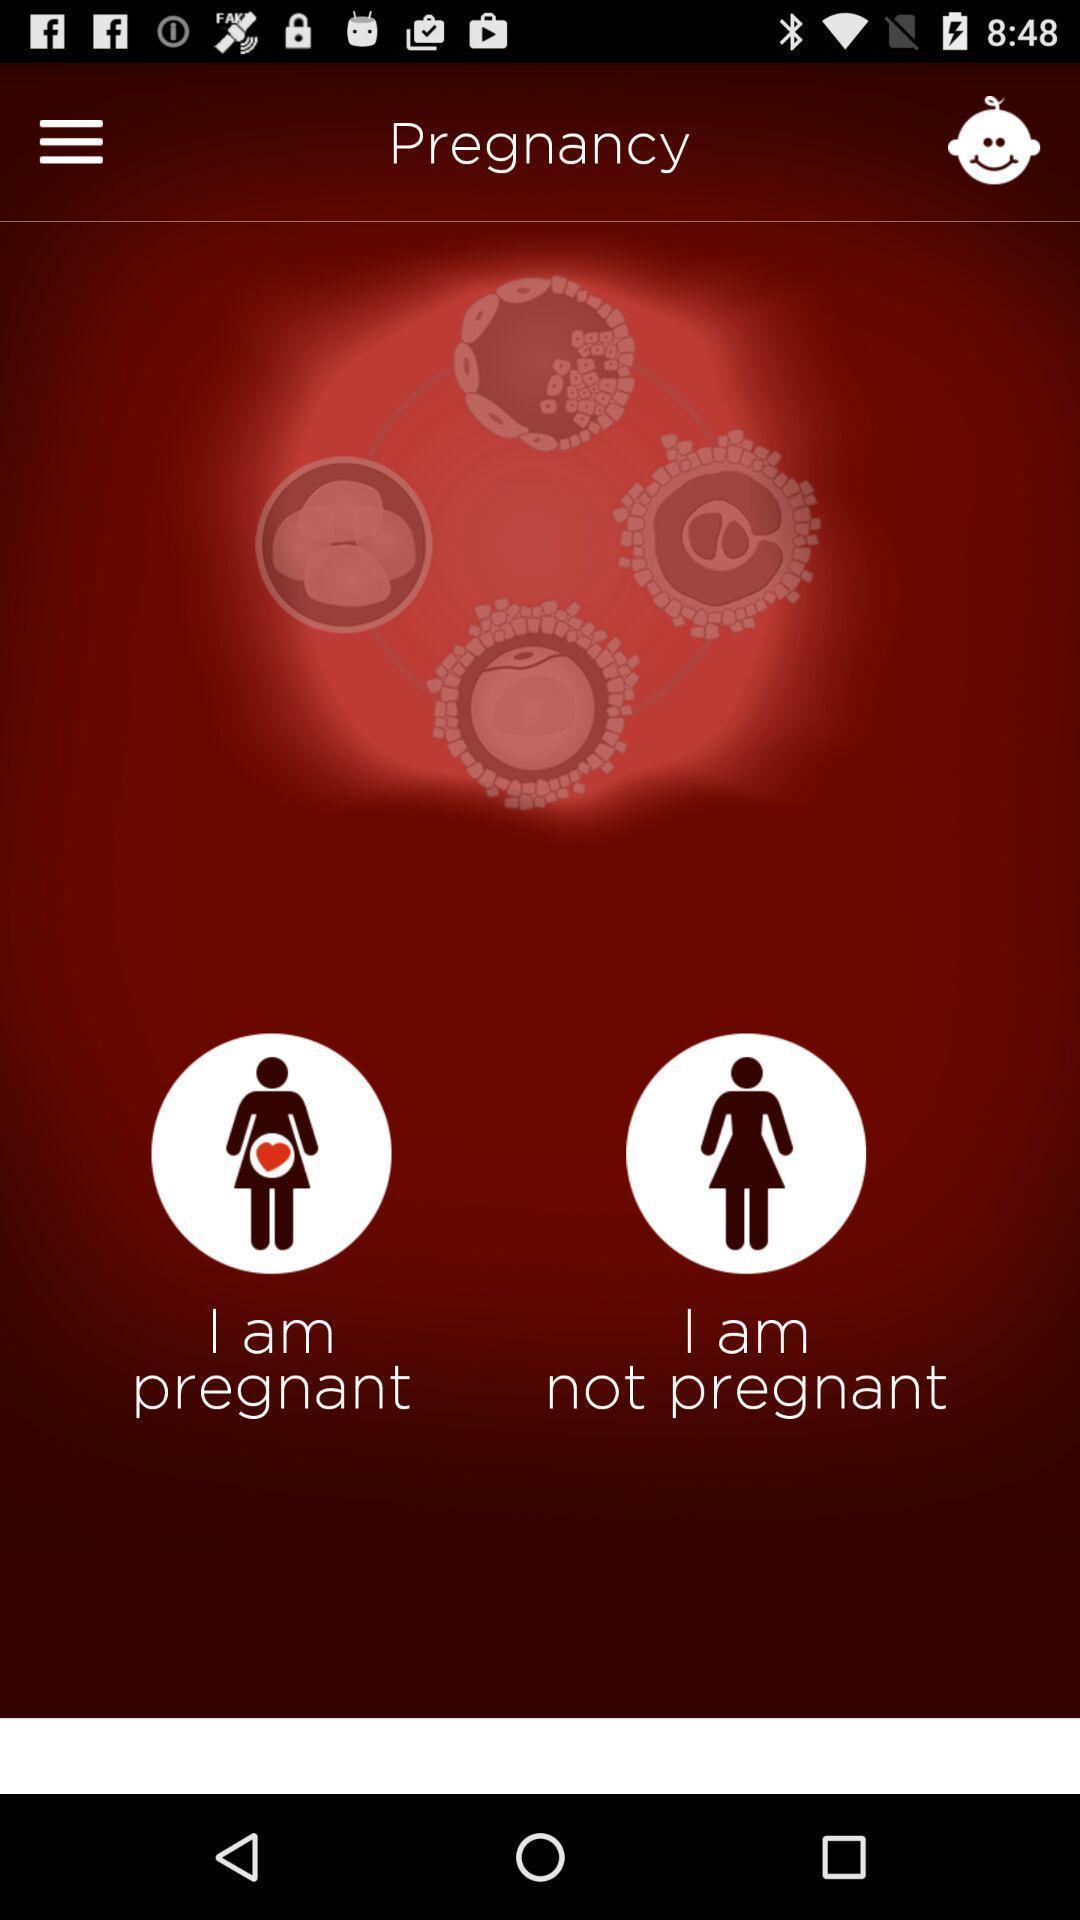Provide a description of this screenshot. Screen displaying the pregnancy app. 